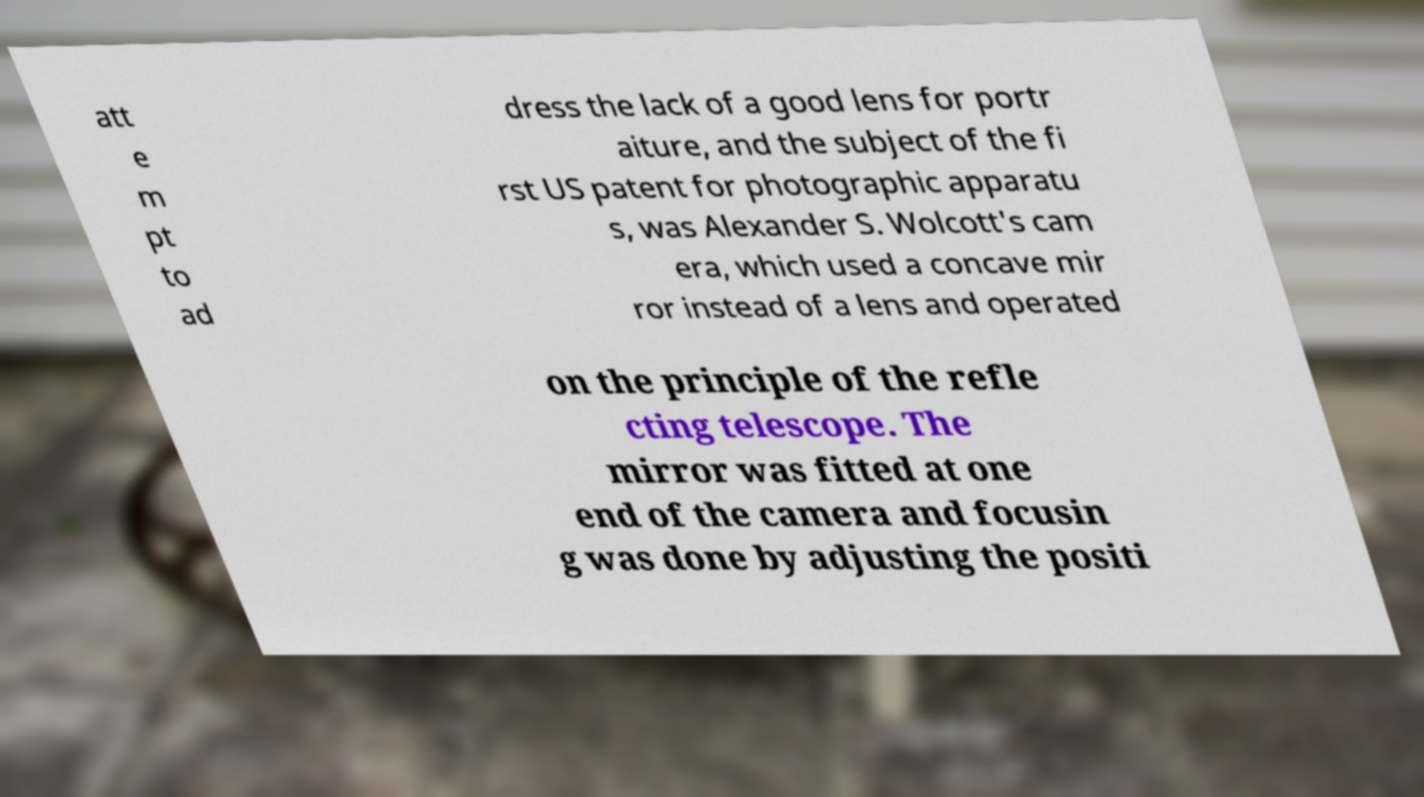Please read and relay the text visible in this image. What does it say? att e m pt to ad dress the lack of a good lens for portr aiture, and the subject of the fi rst US patent for photographic apparatu s, was Alexander S. Wolcott's cam era, which used a concave mir ror instead of a lens and operated on the principle of the refle cting telescope. The mirror was fitted at one end of the camera and focusin g was done by adjusting the positi 